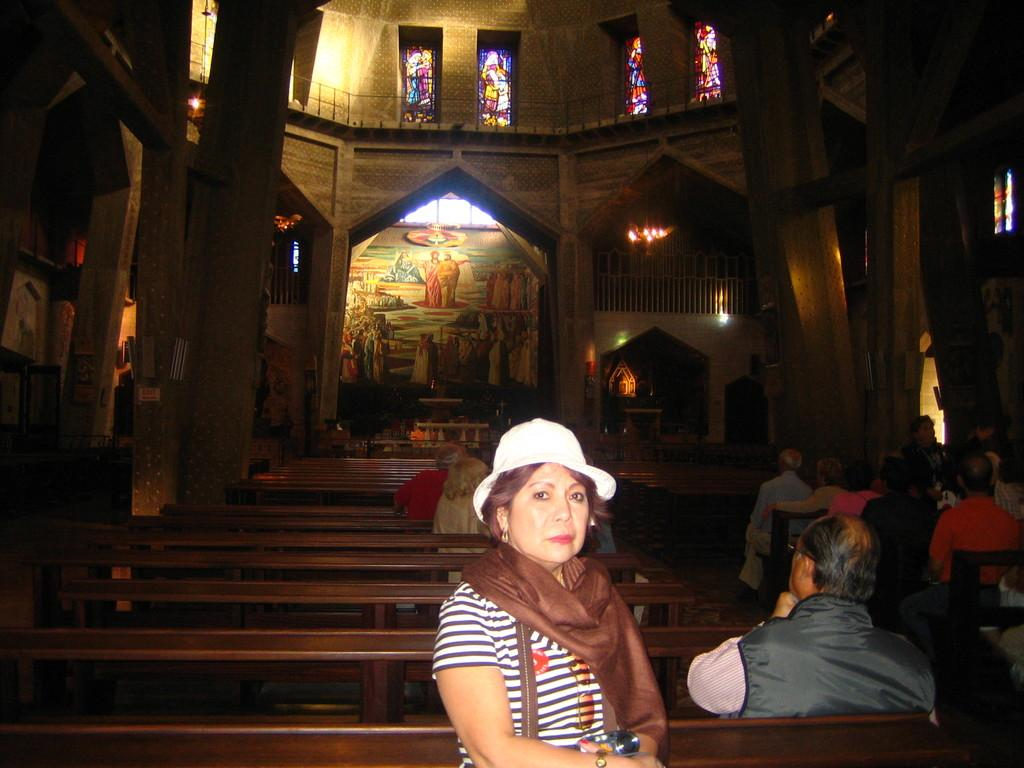Where is the location of the image? The image is inside a building. What architectural features can be seen in the image? There are windows and pillars in the image. What are people doing in the image? People are sitting on benches in the image. What type of artwork is present in the image? There is a painting on the wall in the image. How many waves can be seen crashing against the shore in the image? There are no waves present in the image, as it is set inside a building. 